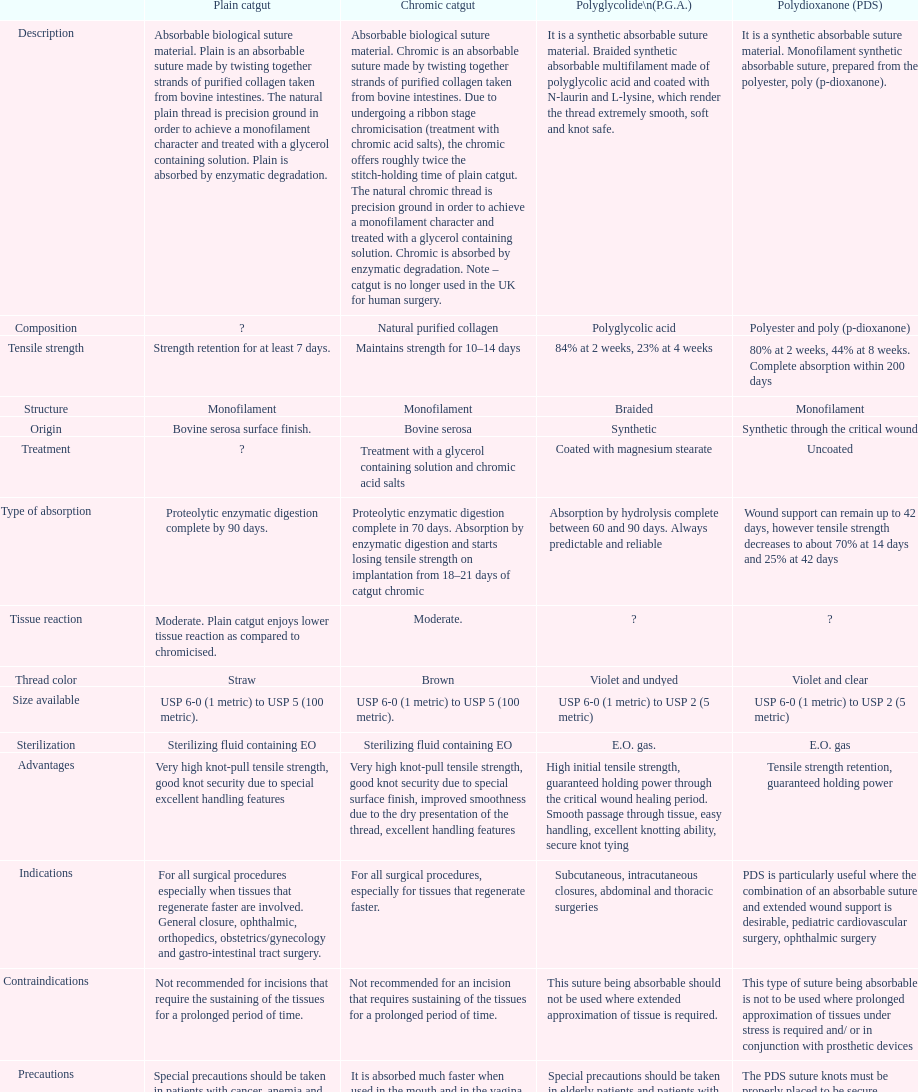Which suture can remain to at most 42 days Polydioxanone (PDS). 